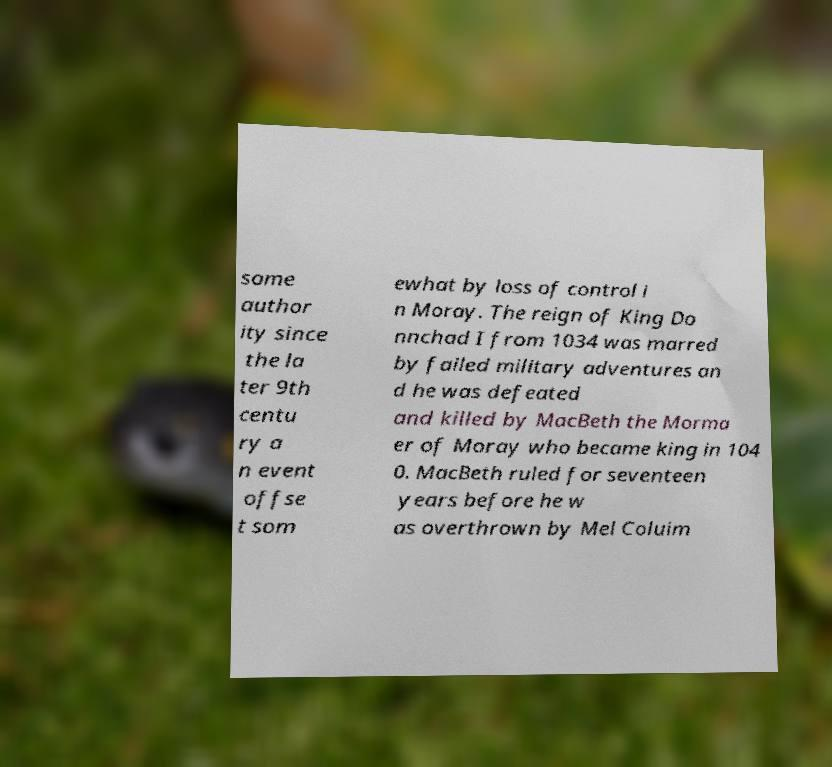Please identify and transcribe the text found in this image. some author ity since the la ter 9th centu ry a n event offse t som ewhat by loss of control i n Moray. The reign of King Do nnchad I from 1034 was marred by failed military adventures an d he was defeated and killed by MacBeth the Morma er of Moray who became king in 104 0. MacBeth ruled for seventeen years before he w as overthrown by Mel Coluim 